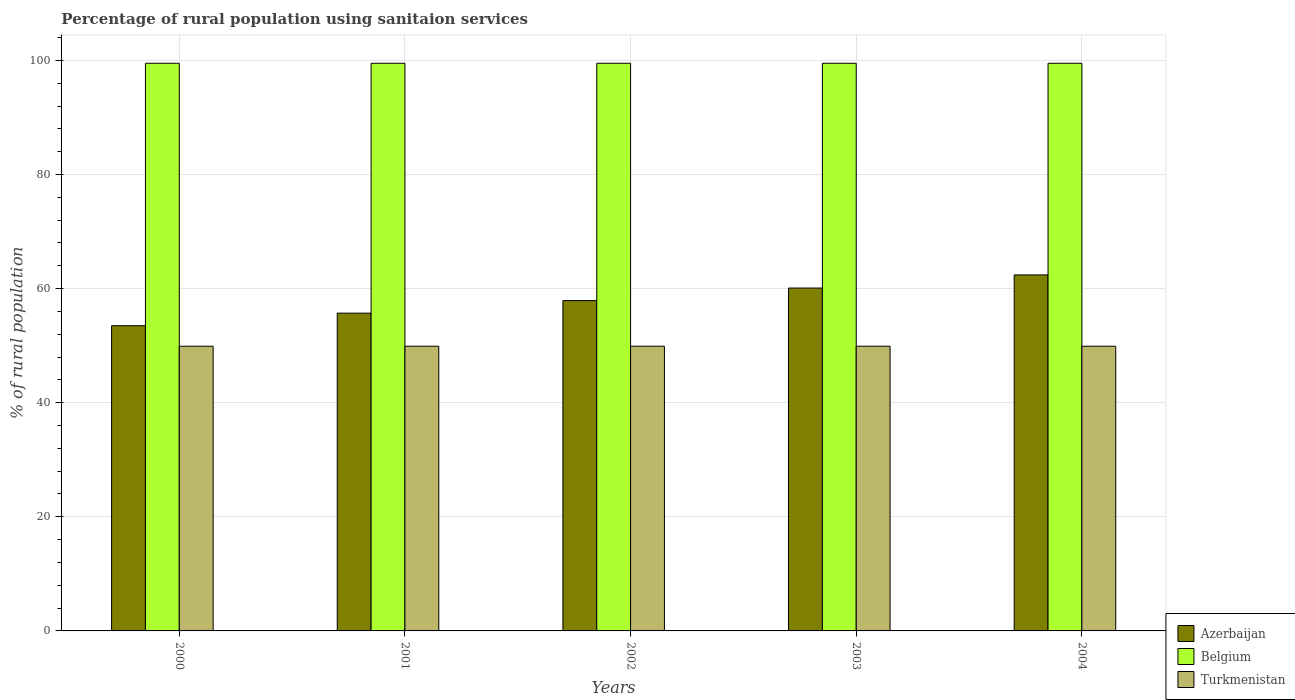How many groups of bars are there?
Your answer should be compact. 5. Are the number of bars per tick equal to the number of legend labels?
Provide a short and direct response. Yes. Are the number of bars on each tick of the X-axis equal?
Keep it short and to the point. Yes. How many bars are there on the 5th tick from the right?
Offer a very short reply. 3. What is the label of the 2nd group of bars from the left?
Your answer should be very brief. 2001. What is the percentage of rural population using sanitaion services in Azerbaijan in 2001?
Give a very brief answer. 55.7. Across all years, what is the maximum percentage of rural population using sanitaion services in Turkmenistan?
Your answer should be very brief. 49.9. Across all years, what is the minimum percentage of rural population using sanitaion services in Turkmenistan?
Your answer should be compact. 49.9. In which year was the percentage of rural population using sanitaion services in Turkmenistan maximum?
Make the answer very short. 2000. What is the total percentage of rural population using sanitaion services in Turkmenistan in the graph?
Offer a terse response. 249.5. What is the difference between the percentage of rural population using sanitaion services in Belgium in 2003 and the percentage of rural population using sanitaion services in Azerbaijan in 2001?
Keep it short and to the point. 43.8. What is the average percentage of rural population using sanitaion services in Azerbaijan per year?
Ensure brevity in your answer.  57.92. In the year 2001, what is the difference between the percentage of rural population using sanitaion services in Belgium and percentage of rural population using sanitaion services in Turkmenistan?
Offer a terse response. 49.6. In how many years, is the percentage of rural population using sanitaion services in Turkmenistan greater than 36 %?
Ensure brevity in your answer.  5. What is the ratio of the percentage of rural population using sanitaion services in Belgium in 2002 to that in 2004?
Your response must be concise. 1. Is the difference between the percentage of rural population using sanitaion services in Belgium in 2000 and 2003 greater than the difference between the percentage of rural population using sanitaion services in Turkmenistan in 2000 and 2003?
Keep it short and to the point. No. What is the difference between the highest and the second highest percentage of rural population using sanitaion services in Turkmenistan?
Provide a succinct answer. 0. What is the difference between the highest and the lowest percentage of rural population using sanitaion services in Belgium?
Offer a terse response. 0. In how many years, is the percentage of rural population using sanitaion services in Belgium greater than the average percentage of rural population using sanitaion services in Belgium taken over all years?
Your response must be concise. 0. What does the 1st bar from the left in 2003 represents?
Give a very brief answer. Azerbaijan. What does the 3rd bar from the right in 2002 represents?
Make the answer very short. Azerbaijan. How many bars are there?
Give a very brief answer. 15. How many years are there in the graph?
Provide a succinct answer. 5. What is the title of the graph?
Make the answer very short. Percentage of rural population using sanitaion services. Does "St. Lucia" appear as one of the legend labels in the graph?
Offer a very short reply. No. What is the label or title of the Y-axis?
Your response must be concise. % of rural population. What is the % of rural population of Azerbaijan in 2000?
Your response must be concise. 53.5. What is the % of rural population in Belgium in 2000?
Provide a short and direct response. 99.5. What is the % of rural population of Turkmenistan in 2000?
Offer a very short reply. 49.9. What is the % of rural population in Azerbaijan in 2001?
Your response must be concise. 55.7. What is the % of rural population in Belgium in 2001?
Offer a very short reply. 99.5. What is the % of rural population of Turkmenistan in 2001?
Keep it short and to the point. 49.9. What is the % of rural population of Azerbaijan in 2002?
Your response must be concise. 57.9. What is the % of rural population of Belgium in 2002?
Your response must be concise. 99.5. What is the % of rural population in Turkmenistan in 2002?
Give a very brief answer. 49.9. What is the % of rural population in Azerbaijan in 2003?
Keep it short and to the point. 60.1. What is the % of rural population of Belgium in 2003?
Provide a short and direct response. 99.5. What is the % of rural population in Turkmenistan in 2003?
Make the answer very short. 49.9. What is the % of rural population of Azerbaijan in 2004?
Your response must be concise. 62.4. What is the % of rural population of Belgium in 2004?
Your response must be concise. 99.5. What is the % of rural population in Turkmenistan in 2004?
Ensure brevity in your answer.  49.9. Across all years, what is the maximum % of rural population in Azerbaijan?
Your answer should be compact. 62.4. Across all years, what is the maximum % of rural population of Belgium?
Your answer should be compact. 99.5. Across all years, what is the maximum % of rural population of Turkmenistan?
Keep it short and to the point. 49.9. Across all years, what is the minimum % of rural population of Azerbaijan?
Your answer should be very brief. 53.5. Across all years, what is the minimum % of rural population of Belgium?
Ensure brevity in your answer.  99.5. Across all years, what is the minimum % of rural population of Turkmenistan?
Provide a short and direct response. 49.9. What is the total % of rural population of Azerbaijan in the graph?
Give a very brief answer. 289.6. What is the total % of rural population in Belgium in the graph?
Provide a succinct answer. 497.5. What is the total % of rural population of Turkmenistan in the graph?
Your response must be concise. 249.5. What is the difference between the % of rural population in Turkmenistan in 2000 and that in 2001?
Keep it short and to the point. 0. What is the difference between the % of rural population of Azerbaijan in 2000 and that in 2002?
Make the answer very short. -4.4. What is the difference between the % of rural population of Belgium in 2000 and that in 2002?
Offer a terse response. 0. What is the difference between the % of rural population of Azerbaijan in 2000 and that in 2003?
Make the answer very short. -6.6. What is the difference between the % of rural population in Belgium in 2000 and that in 2003?
Your answer should be very brief. 0. What is the difference between the % of rural population in Turkmenistan in 2000 and that in 2003?
Make the answer very short. 0. What is the difference between the % of rural population of Azerbaijan in 2000 and that in 2004?
Ensure brevity in your answer.  -8.9. What is the difference between the % of rural population in Belgium in 2000 and that in 2004?
Give a very brief answer. 0. What is the difference between the % of rural population of Turkmenistan in 2000 and that in 2004?
Ensure brevity in your answer.  0. What is the difference between the % of rural population of Belgium in 2001 and that in 2002?
Give a very brief answer. 0. What is the difference between the % of rural population in Turkmenistan in 2001 and that in 2004?
Your answer should be very brief. 0. What is the difference between the % of rural population in Azerbaijan in 2002 and that in 2003?
Make the answer very short. -2.2. What is the difference between the % of rural population in Turkmenistan in 2002 and that in 2003?
Keep it short and to the point. 0. What is the difference between the % of rural population of Belgium in 2003 and that in 2004?
Give a very brief answer. 0. What is the difference between the % of rural population in Turkmenistan in 2003 and that in 2004?
Make the answer very short. 0. What is the difference between the % of rural population of Azerbaijan in 2000 and the % of rural population of Belgium in 2001?
Provide a short and direct response. -46. What is the difference between the % of rural population of Azerbaijan in 2000 and the % of rural population of Turkmenistan in 2001?
Your response must be concise. 3.6. What is the difference between the % of rural population of Belgium in 2000 and the % of rural population of Turkmenistan in 2001?
Offer a terse response. 49.6. What is the difference between the % of rural population of Azerbaijan in 2000 and the % of rural population of Belgium in 2002?
Your answer should be very brief. -46. What is the difference between the % of rural population in Azerbaijan in 2000 and the % of rural population in Turkmenistan in 2002?
Your response must be concise. 3.6. What is the difference between the % of rural population in Belgium in 2000 and the % of rural population in Turkmenistan in 2002?
Keep it short and to the point. 49.6. What is the difference between the % of rural population of Azerbaijan in 2000 and the % of rural population of Belgium in 2003?
Provide a short and direct response. -46. What is the difference between the % of rural population in Belgium in 2000 and the % of rural population in Turkmenistan in 2003?
Provide a succinct answer. 49.6. What is the difference between the % of rural population in Azerbaijan in 2000 and the % of rural population in Belgium in 2004?
Your response must be concise. -46. What is the difference between the % of rural population of Belgium in 2000 and the % of rural population of Turkmenistan in 2004?
Your answer should be compact. 49.6. What is the difference between the % of rural population of Azerbaijan in 2001 and the % of rural population of Belgium in 2002?
Give a very brief answer. -43.8. What is the difference between the % of rural population of Azerbaijan in 2001 and the % of rural population of Turkmenistan in 2002?
Provide a short and direct response. 5.8. What is the difference between the % of rural population in Belgium in 2001 and the % of rural population in Turkmenistan in 2002?
Ensure brevity in your answer.  49.6. What is the difference between the % of rural population in Azerbaijan in 2001 and the % of rural population in Belgium in 2003?
Make the answer very short. -43.8. What is the difference between the % of rural population in Azerbaijan in 2001 and the % of rural population in Turkmenistan in 2003?
Your answer should be compact. 5.8. What is the difference between the % of rural population in Belgium in 2001 and the % of rural population in Turkmenistan in 2003?
Provide a short and direct response. 49.6. What is the difference between the % of rural population of Azerbaijan in 2001 and the % of rural population of Belgium in 2004?
Your answer should be very brief. -43.8. What is the difference between the % of rural population of Azerbaijan in 2001 and the % of rural population of Turkmenistan in 2004?
Offer a very short reply. 5.8. What is the difference between the % of rural population of Belgium in 2001 and the % of rural population of Turkmenistan in 2004?
Provide a short and direct response. 49.6. What is the difference between the % of rural population of Azerbaijan in 2002 and the % of rural population of Belgium in 2003?
Give a very brief answer. -41.6. What is the difference between the % of rural population in Belgium in 2002 and the % of rural population in Turkmenistan in 2003?
Your response must be concise. 49.6. What is the difference between the % of rural population in Azerbaijan in 2002 and the % of rural population in Belgium in 2004?
Offer a very short reply. -41.6. What is the difference between the % of rural population in Belgium in 2002 and the % of rural population in Turkmenistan in 2004?
Your response must be concise. 49.6. What is the difference between the % of rural population of Azerbaijan in 2003 and the % of rural population of Belgium in 2004?
Your answer should be very brief. -39.4. What is the difference between the % of rural population in Azerbaijan in 2003 and the % of rural population in Turkmenistan in 2004?
Make the answer very short. 10.2. What is the difference between the % of rural population in Belgium in 2003 and the % of rural population in Turkmenistan in 2004?
Make the answer very short. 49.6. What is the average % of rural population in Azerbaijan per year?
Offer a terse response. 57.92. What is the average % of rural population in Belgium per year?
Your answer should be very brief. 99.5. What is the average % of rural population in Turkmenistan per year?
Your answer should be very brief. 49.9. In the year 2000, what is the difference between the % of rural population in Azerbaijan and % of rural population in Belgium?
Your answer should be very brief. -46. In the year 2000, what is the difference between the % of rural population of Belgium and % of rural population of Turkmenistan?
Keep it short and to the point. 49.6. In the year 2001, what is the difference between the % of rural population in Azerbaijan and % of rural population in Belgium?
Offer a very short reply. -43.8. In the year 2001, what is the difference between the % of rural population in Azerbaijan and % of rural population in Turkmenistan?
Keep it short and to the point. 5.8. In the year 2001, what is the difference between the % of rural population of Belgium and % of rural population of Turkmenistan?
Give a very brief answer. 49.6. In the year 2002, what is the difference between the % of rural population of Azerbaijan and % of rural population of Belgium?
Provide a succinct answer. -41.6. In the year 2002, what is the difference between the % of rural population of Azerbaijan and % of rural population of Turkmenistan?
Give a very brief answer. 8. In the year 2002, what is the difference between the % of rural population in Belgium and % of rural population in Turkmenistan?
Provide a succinct answer. 49.6. In the year 2003, what is the difference between the % of rural population of Azerbaijan and % of rural population of Belgium?
Provide a short and direct response. -39.4. In the year 2003, what is the difference between the % of rural population in Azerbaijan and % of rural population in Turkmenistan?
Provide a short and direct response. 10.2. In the year 2003, what is the difference between the % of rural population of Belgium and % of rural population of Turkmenistan?
Give a very brief answer. 49.6. In the year 2004, what is the difference between the % of rural population of Azerbaijan and % of rural population of Belgium?
Your answer should be compact. -37.1. In the year 2004, what is the difference between the % of rural population in Belgium and % of rural population in Turkmenistan?
Offer a very short reply. 49.6. What is the ratio of the % of rural population in Azerbaijan in 2000 to that in 2001?
Ensure brevity in your answer.  0.96. What is the ratio of the % of rural population in Azerbaijan in 2000 to that in 2002?
Give a very brief answer. 0.92. What is the ratio of the % of rural population in Belgium in 2000 to that in 2002?
Your answer should be very brief. 1. What is the ratio of the % of rural population in Turkmenistan in 2000 to that in 2002?
Your response must be concise. 1. What is the ratio of the % of rural population in Azerbaijan in 2000 to that in 2003?
Make the answer very short. 0.89. What is the ratio of the % of rural population of Belgium in 2000 to that in 2003?
Provide a succinct answer. 1. What is the ratio of the % of rural population in Turkmenistan in 2000 to that in 2003?
Ensure brevity in your answer.  1. What is the ratio of the % of rural population in Azerbaijan in 2000 to that in 2004?
Offer a terse response. 0.86. What is the ratio of the % of rural population of Turkmenistan in 2000 to that in 2004?
Offer a terse response. 1. What is the ratio of the % of rural population in Azerbaijan in 2001 to that in 2002?
Give a very brief answer. 0.96. What is the ratio of the % of rural population of Turkmenistan in 2001 to that in 2002?
Your response must be concise. 1. What is the ratio of the % of rural population of Azerbaijan in 2001 to that in 2003?
Keep it short and to the point. 0.93. What is the ratio of the % of rural population in Turkmenistan in 2001 to that in 2003?
Make the answer very short. 1. What is the ratio of the % of rural population of Azerbaijan in 2001 to that in 2004?
Your response must be concise. 0.89. What is the ratio of the % of rural population in Azerbaijan in 2002 to that in 2003?
Ensure brevity in your answer.  0.96. What is the ratio of the % of rural population of Turkmenistan in 2002 to that in 2003?
Give a very brief answer. 1. What is the ratio of the % of rural population of Azerbaijan in 2002 to that in 2004?
Your response must be concise. 0.93. What is the ratio of the % of rural population of Azerbaijan in 2003 to that in 2004?
Your answer should be very brief. 0.96. What is the ratio of the % of rural population of Belgium in 2003 to that in 2004?
Give a very brief answer. 1. What is the ratio of the % of rural population in Turkmenistan in 2003 to that in 2004?
Make the answer very short. 1. What is the difference between the highest and the second highest % of rural population in Turkmenistan?
Give a very brief answer. 0. What is the difference between the highest and the lowest % of rural population of Azerbaijan?
Your answer should be compact. 8.9. 